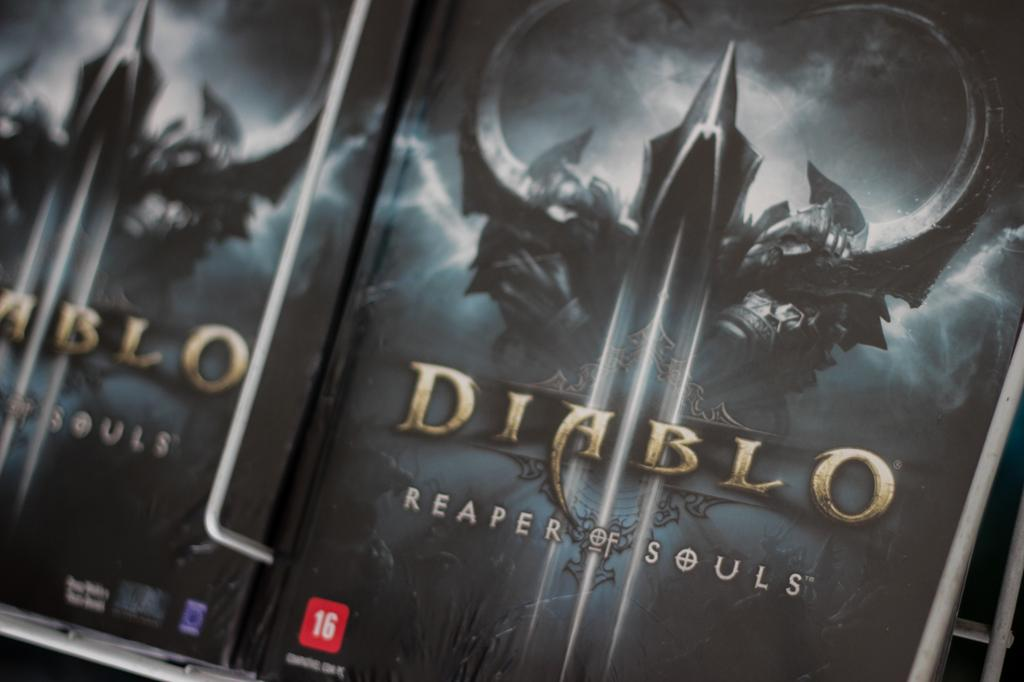<image>
Summarize the visual content of the image. Cover for a video game that says DIablo on it. 